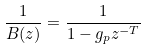Convert formula to latex. <formula><loc_0><loc_0><loc_500><loc_500>\frac { 1 } { B ( z ) } = \frac { 1 } { 1 - g _ { p } z ^ { - T } }</formula> 